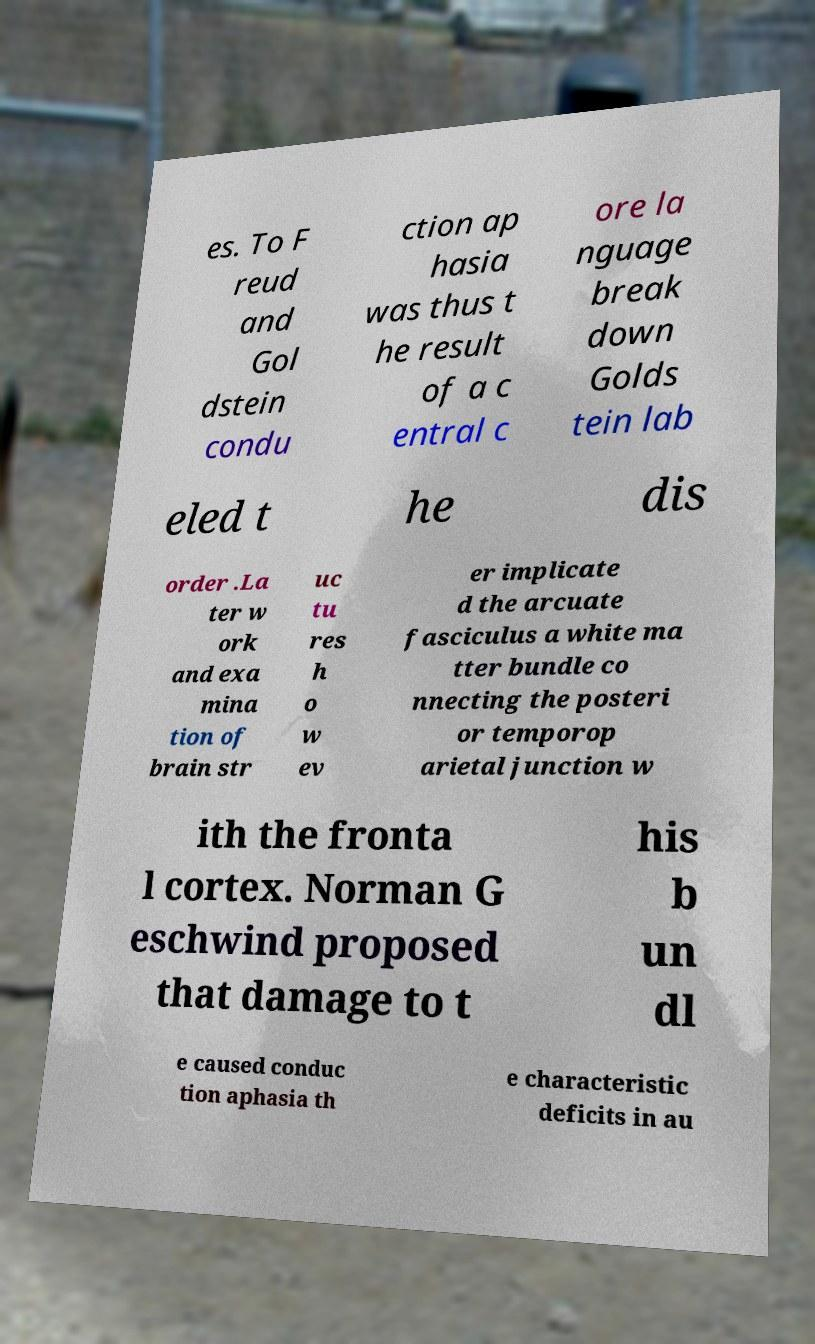Please read and relay the text visible in this image. What does it say? es. To F reud and Gol dstein condu ction ap hasia was thus t he result of a c entral c ore la nguage break down Golds tein lab eled t he dis order .La ter w ork and exa mina tion of brain str uc tu res h o w ev er implicate d the arcuate fasciculus a white ma tter bundle co nnecting the posteri or temporop arietal junction w ith the fronta l cortex. Norman G eschwind proposed that damage to t his b un dl e caused conduc tion aphasia th e characteristic deficits in au 